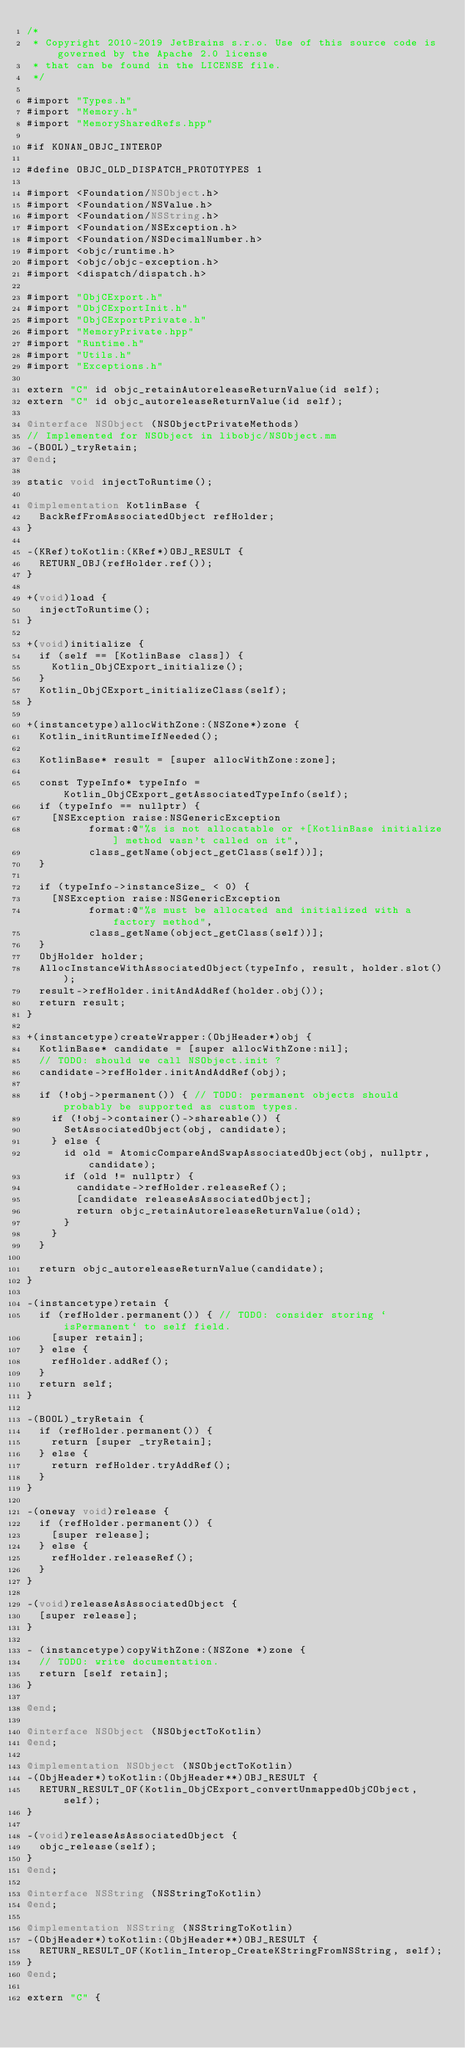<code> <loc_0><loc_0><loc_500><loc_500><_ObjectiveC_>/*
 * Copyright 2010-2019 JetBrains s.r.o. Use of this source code is governed by the Apache 2.0 license
 * that can be found in the LICENSE file.
 */

#import "Types.h"
#import "Memory.h"
#import "MemorySharedRefs.hpp"

#if KONAN_OBJC_INTEROP

#define OBJC_OLD_DISPATCH_PROTOTYPES 1

#import <Foundation/NSObject.h>
#import <Foundation/NSValue.h>
#import <Foundation/NSString.h>
#import <Foundation/NSException.h>
#import <Foundation/NSDecimalNumber.h>
#import <objc/runtime.h>
#import <objc/objc-exception.h>
#import <dispatch/dispatch.h>

#import "ObjCExport.h"
#import "ObjCExportInit.h"
#import "ObjCExportPrivate.h"
#import "MemoryPrivate.hpp"
#import "Runtime.h"
#import "Utils.h"
#import "Exceptions.h"

extern "C" id objc_retainAutoreleaseReturnValue(id self);
extern "C" id objc_autoreleaseReturnValue(id self);

@interface NSObject (NSObjectPrivateMethods)
// Implemented for NSObject in libobjc/NSObject.mm
-(BOOL)_tryRetain;
@end;

static void injectToRuntime();

@implementation KotlinBase {
  BackRefFromAssociatedObject refHolder;
}

-(KRef)toKotlin:(KRef*)OBJ_RESULT {
  RETURN_OBJ(refHolder.ref());
}

+(void)load {
  injectToRuntime();
}

+(void)initialize {
  if (self == [KotlinBase class]) {
    Kotlin_ObjCExport_initialize();
  }
  Kotlin_ObjCExport_initializeClass(self);
}

+(instancetype)allocWithZone:(NSZone*)zone {
  Kotlin_initRuntimeIfNeeded();

  KotlinBase* result = [super allocWithZone:zone];

  const TypeInfo* typeInfo = Kotlin_ObjCExport_getAssociatedTypeInfo(self);
  if (typeInfo == nullptr) {
    [NSException raise:NSGenericException
          format:@"%s is not allocatable or +[KotlinBase initialize] method wasn't called on it",
          class_getName(object_getClass(self))];
  }

  if (typeInfo->instanceSize_ < 0) {
    [NSException raise:NSGenericException
          format:@"%s must be allocated and initialized with a factory method",
          class_getName(object_getClass(self))];
  }
  ObjHolder holder;
  AllocInstanceWithAssociatedObject(typeInfo, result, holder.slot());
  result->refHolder.initAndAddRef(holder.obj());
  return result;
}

+(instancetype)createWrapper:(ObjHeader*)obj {
  KotlinBase* candidate = [super allocWithZone:nil];
  // TODO: should we call NSObject.init ?
  candidate->refHolder.initAndAddRef(obj);

  if (!obj->permanent()) { // TODO: permanent objects should probably be supported as custom types.
    if (!obj->container()->shareable()) {
      SetAssociatedObject(obj, candidate);
    } else {
      id old = AtomicCompareAndSwapAssociatedObject(obj, nullptr, candidate);
      if (old != nullptr) {
        candidate->refHolder.releaseRef();
        [candidate releaseAsAssociatedObject];
        return objc_retainAutoreleaseReturnValue(old);
      }
    }
  }

  return objc_autoreleaseReturnValue(candidate);
}

-(instancetype)retain {
  if (refHolder.permanent()) { // TODO: consider storing `isPermanent` to self field.
    [super retain];
  } else {
    refHolder.addRef();
  }
  return self;
}

-(BOOL)_tryRetain {
  if (refHolder.permanent()) {
    return [super _tryRetain];
  } else {
    return refHolder.tryAddRef();
  }
}

-(oneway void)release {
  if (refHolder.permanent()) {
    [super release];
  } else {
    refHolder.releaseRef();
  }
}

-(void)releaseAsAssociatedObject {
  [super release];
}

- (instancetype)copyWithZone:(NSZone *)zone {
  // TODO: write documentation.
  return [self retain];
}

@end;

@interface NSObject (NSObjectToKotlin)
@end;

@implementation NSObject (NSObjectToKotlin)
-(ObjHeader*)toKotlin:(ObjHeader**)OBJ_RESULT {
  RETURN_RESULT_OF(Kotlin_ObjCExport_convertUnmappedObjCObject, self);
}

-(void)releaseAsAssociatedObject {
  objc_release(self);
}
@end;

@interface NSString (NSStringToKotlin)
@end;

@implementation NSString (NSStringToKotlin)
-(ObjHeader*)toKotlin:(ObjHeader**)OBJ_RESULT {
  RETURN_RESULT_OF(Kotlin_Interop_CreateKStringFromNSString, self);
}
@end;

extern "C" {
</code> 